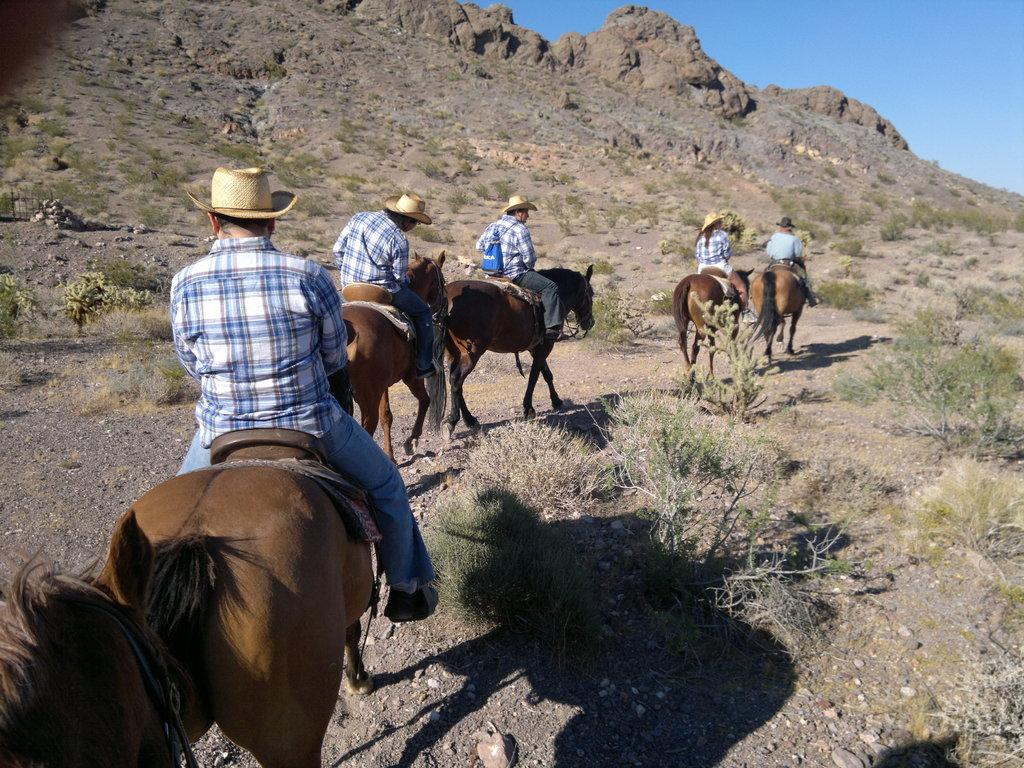What is happening in the image? There is a group of people in the image, and they are seated on horses. What are the people wearing on their heads? The people are wearing caps. What else can be seen in the image besides the people and horses? There are plants visible in the image. What type of pest can be seen crawling on the people's caps in the image? There are no pests visible in the image; the people are wearing caps, but there is no indication of any pests present. 